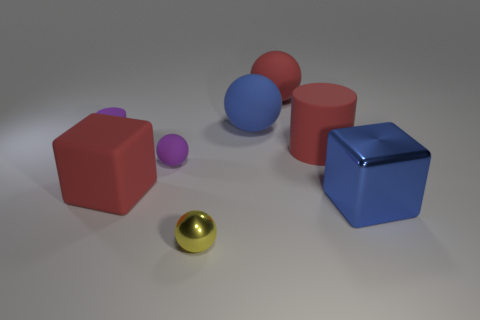Subtract all cyan spheres. Subtract all yellow cylinders. How many spheres are left? 4 Add 1 large red blocks. How many objects exist? 9 Subtract all blocks. How many objects are left? 6 Subtract all tiny gray rubber cylinders. Subtract all large objects. How many objects are left? 3 Add 7 big balls. How many big balls are left? 9 Add 5 large brown shiny blocks. How many large brown shiny blocks exist? 5 Subtract 0 green blocks. How many objects are left? 8 